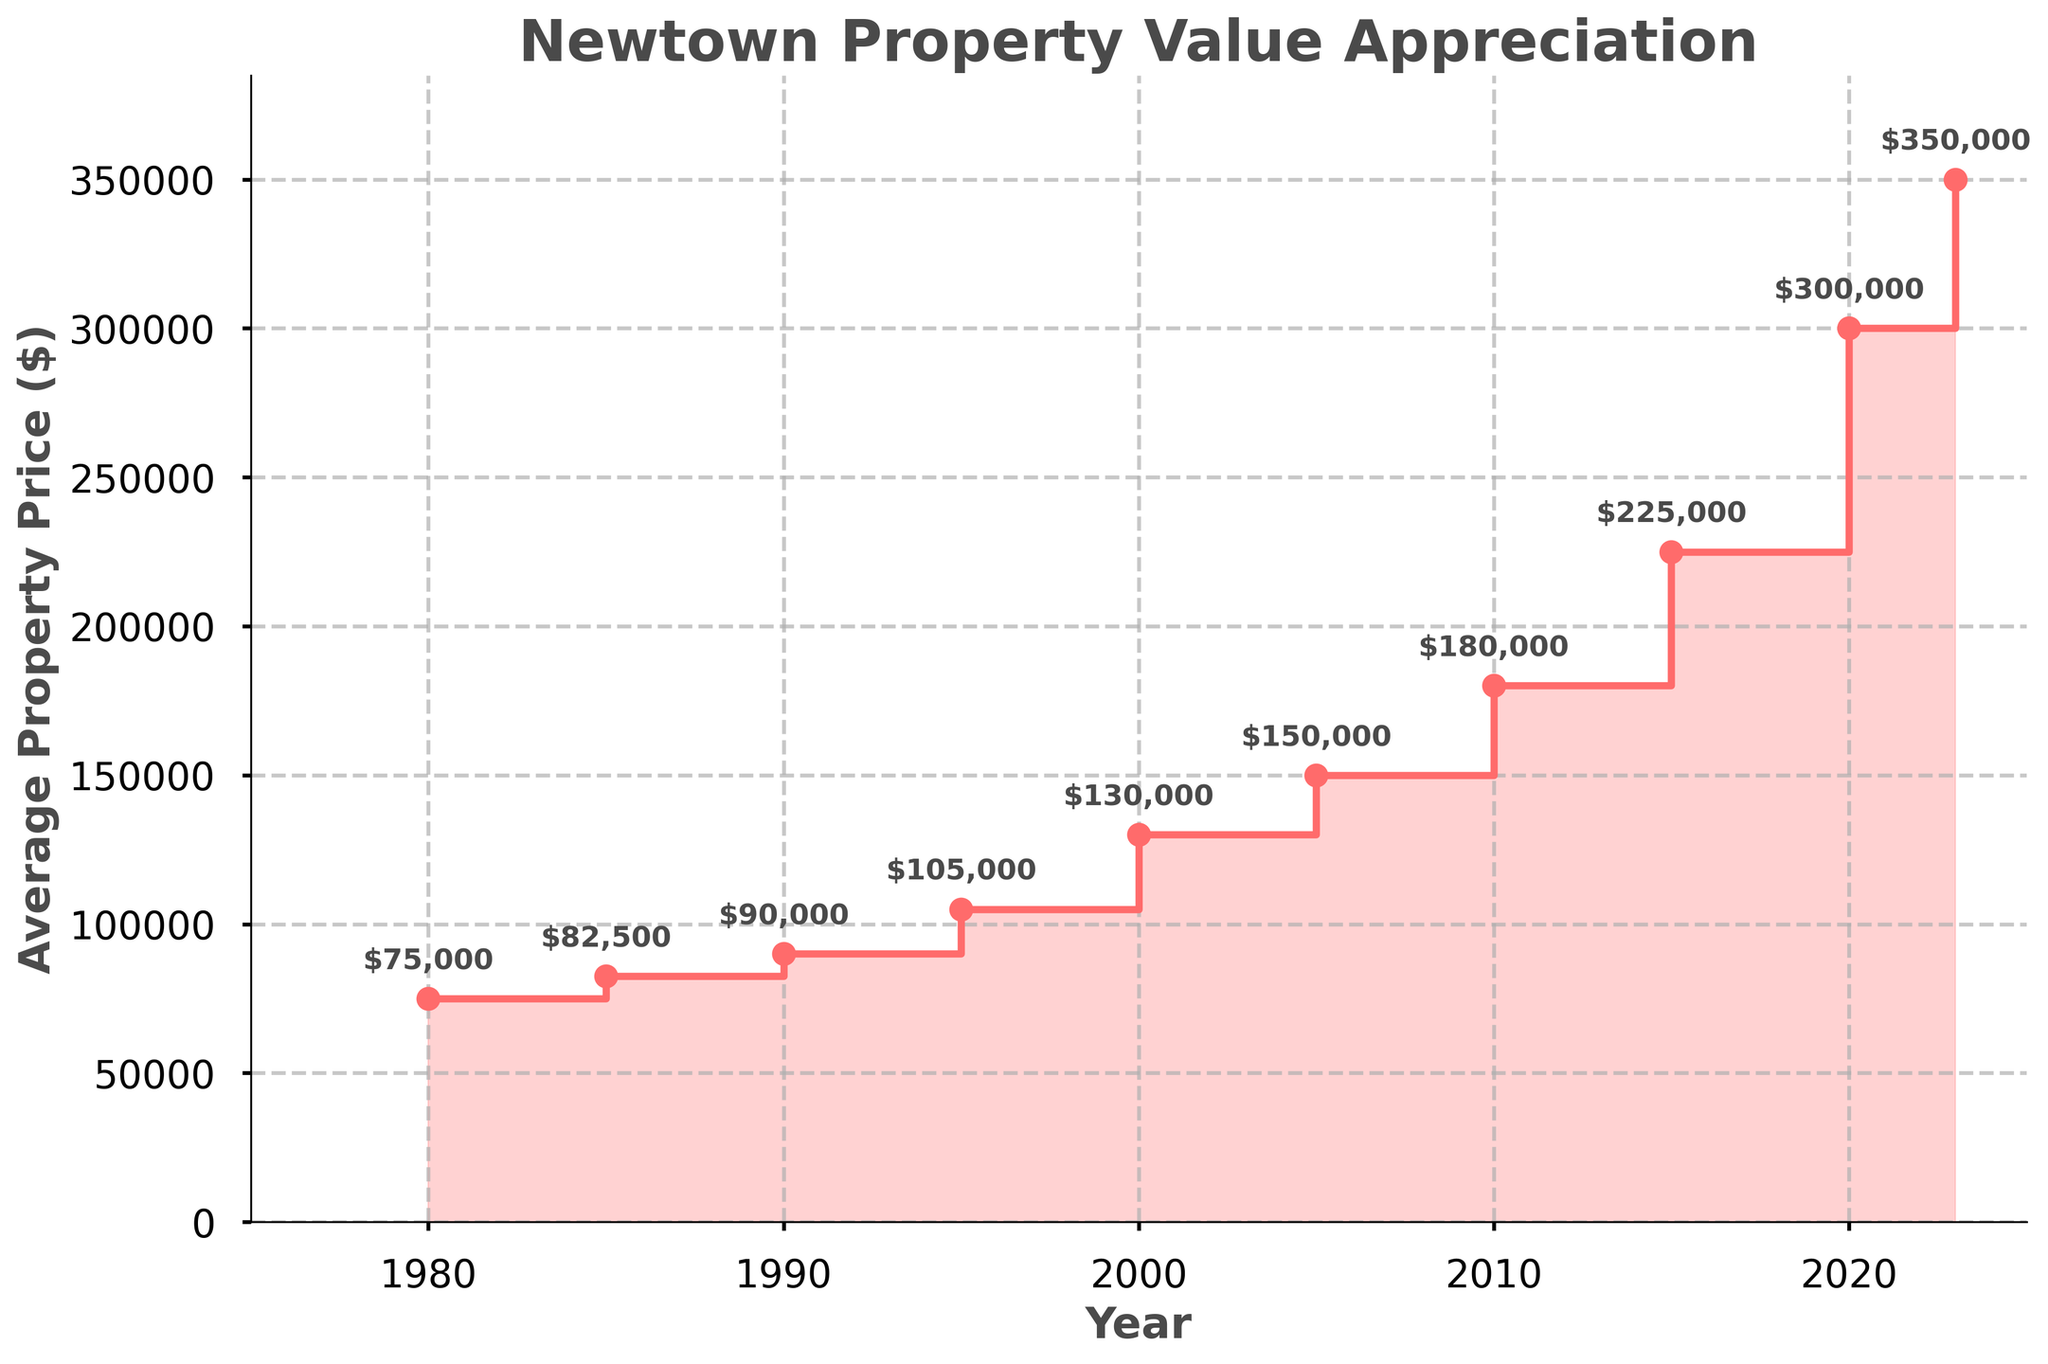When did the average property price reach $300,000? The figure shows the average property prices at various years. The price reaches $300,000 in 2020.
Answer: 2020 What's the percentage increase in the average property price from 1980 to 2023? The average property price in 1980 is $75,000 and in 2023 is $350,000. The percentage increase is calculated by ((350,000 - 75,000) / 75,000) * 100 = 366.67%.
Answer: 366.67% Which year had the highest average property price according to the figure? By looking at the prices on the graph, 2023 shows the highest average property price at $350,000.
Answer: 2023 What was the average property price in 1995? The figure indicates that in the year 1995, the average property price was $105,000.
Answer: $105,000 How many times did the average property price increase between 2005 and 2023? From 2005 to 2023, the average property price increased from $150,000 to $350,000. The number of times the price increased is calculated by dividing 350,000 by 150,000, which equals 2.33 times.
Answer: 2.33 times Is the average property price in 2015 closer to that in 2010 or 2020? The average property price in 2015 is $225,000. The price in 2010 is $180,000, and in 2020 is $300,000. The difference with 2010 is $225,000 - $180,000 = $45,000, and with 2020 is $300,000 - $225,000 = $75,000. $225,000 is closer to $180,000 than $300,000.
Answer: 2010 Which decade saw the highest absolute increase in average property price? By examining decade-by-decade increases: 
1980-1990: $90,000 - $75,000 = $15,000, 
1990-2000: $130,000 - $90,000 = $40,000, 
2000-2010: $180,000 - $130,000 = $50,000,
2010-2020: $300,000 - $180,000 = $120,000.
The largest increase is from 2010 to 2020.
Answer: 2010-2020 Which year had the smallest average property price increase compared to the previous recorded year? Calculate the differences between successive years:
1980-1985: $82,500 - $75,000 = $7,500,
1985-1990: $90,000 - $82,500 = $7,500,
1990-1995: $105,000 - $90,000 = $15,000,
1995-2000: $130,000 - $105,000 = $25,000,
2000-2005: $150,000 - $130,000 = $20,000,
2005-2010: $180,000 - $150,000 = $30,000,
2010-2015: $225,000 - $180,000 = $45,000,
2015-2020: $300,000 - $225,000 = $75,000,
2020-2023: $350,000 - $300,000 = $50,000.
The smallest increase is between 1980 and 1985, and between 1985 and 1990, both are $7,500.
Answer: 1980-1985 and 1985-1990 